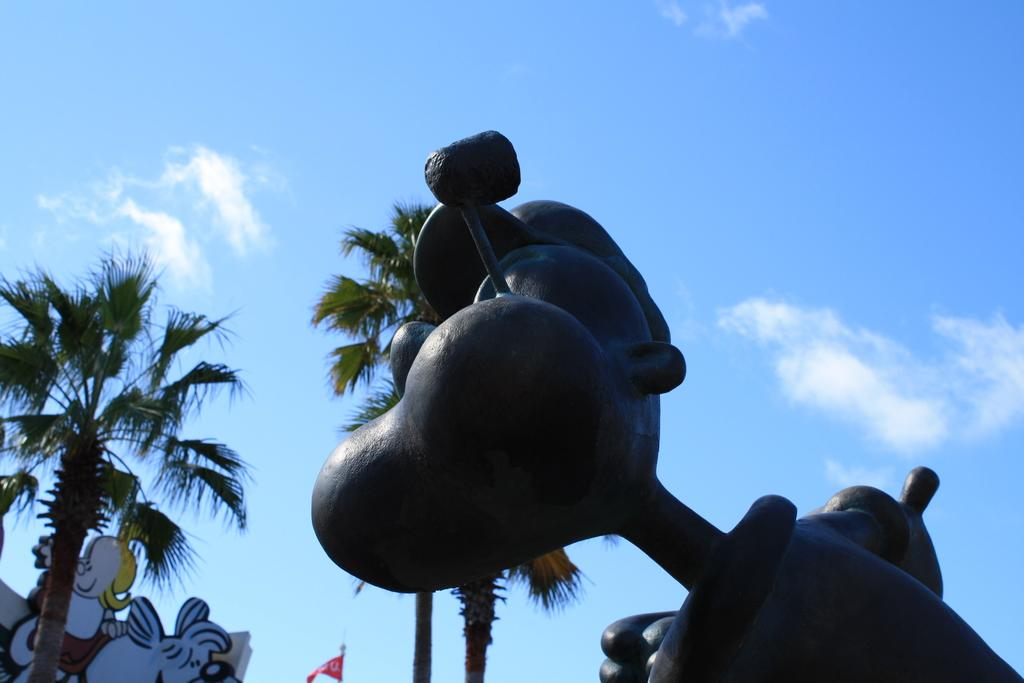What color is the sky in the image? The sky in the image is blue. What type of trees can be seen in the image? There are coconut trees in the image. What kind of statue is present in the image? There is a bronze statue in the image. What type of powder can be seen floating in the air in the image? There is no powder visible in the image; the sky is blue, and there are coconut trees and a bronze statue present. 